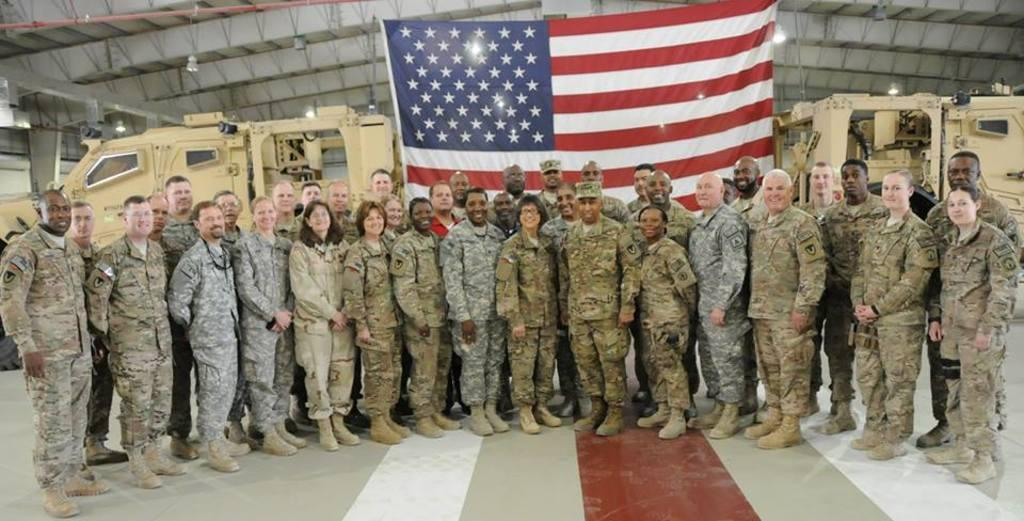How many people are in the image? There is a group of people in the image. What are the people doing in the image? The people are standing and smiling. What can be seen in the background of the image? There is a flag, vehicles, and lights in the background of the image. How many goldfish are swimming in the image? There are no goldfish present in the image. Are there any frogs visible in the image? There are no frogs visible in the image. 